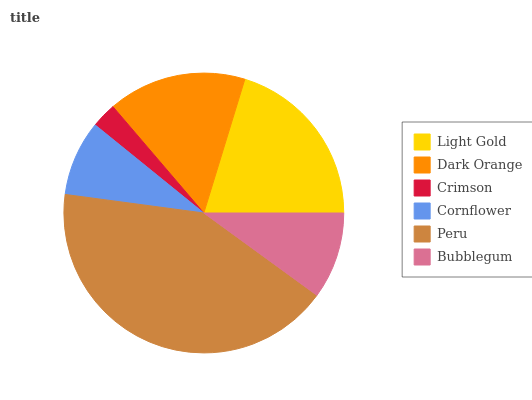Is Crimson the minimum?
Answer yes or no. Yes. Is Peru the maximum?
Answer yes or no. Yes. Is Dark Orange the minimum?
Answer yes or no. No. Is Dark Orange the maximum?
Answer yes or no. No. Is Light Gold greater than Dark Orange?
Answer yes or no. Yes. Is Dark Orange less than Light Gold?
Answer yes or no. Yes. Is Dark Orange greater than Light Gold?
Answer yes or no. No. Is Light Gold less than Dark Orange?
Answer yes or no. No. Is Dark Orange the high median?
Answer yes or no. Yes. Is Bubblegum the low median?
Answer yes or no. Yes. Is Light Gold the high median?
Answer yes or no. No. Is Dark Orange the low median?
Answer yes or no. No. 